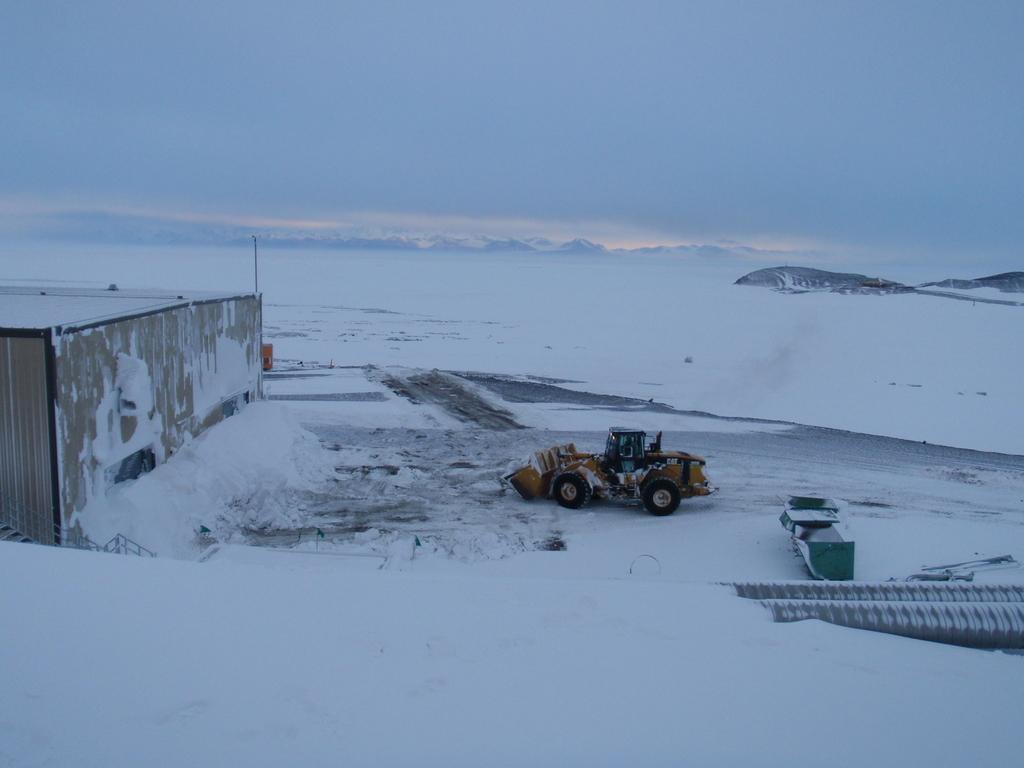How would you summarize this image in a sentence or two? Here in this picture in the middle we can see a crane present on the ground, which is fully covered with snow over there and we can see a shed in front of it and behind it we can see some pipes present over there and in the far we can see mountains covered with snow over there and we can see clouds in the sky. 